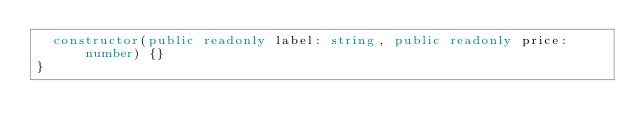Convert code to text. <code><loc_0><loc_0><loc_500><loc_500><_TypeScript_>  constructor(public readonly label: string, public readonly price: number) {}
}
</code> 